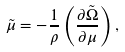Convert formula to latex. <formula><loc_0><loc_0><loc_500><loc_500>\tilde { \mu } = - \frac { 1 } { \rho } \left ( \frac { \partial \tilde { \Omega } } { \partial \mu } \right ) ,</formula> 